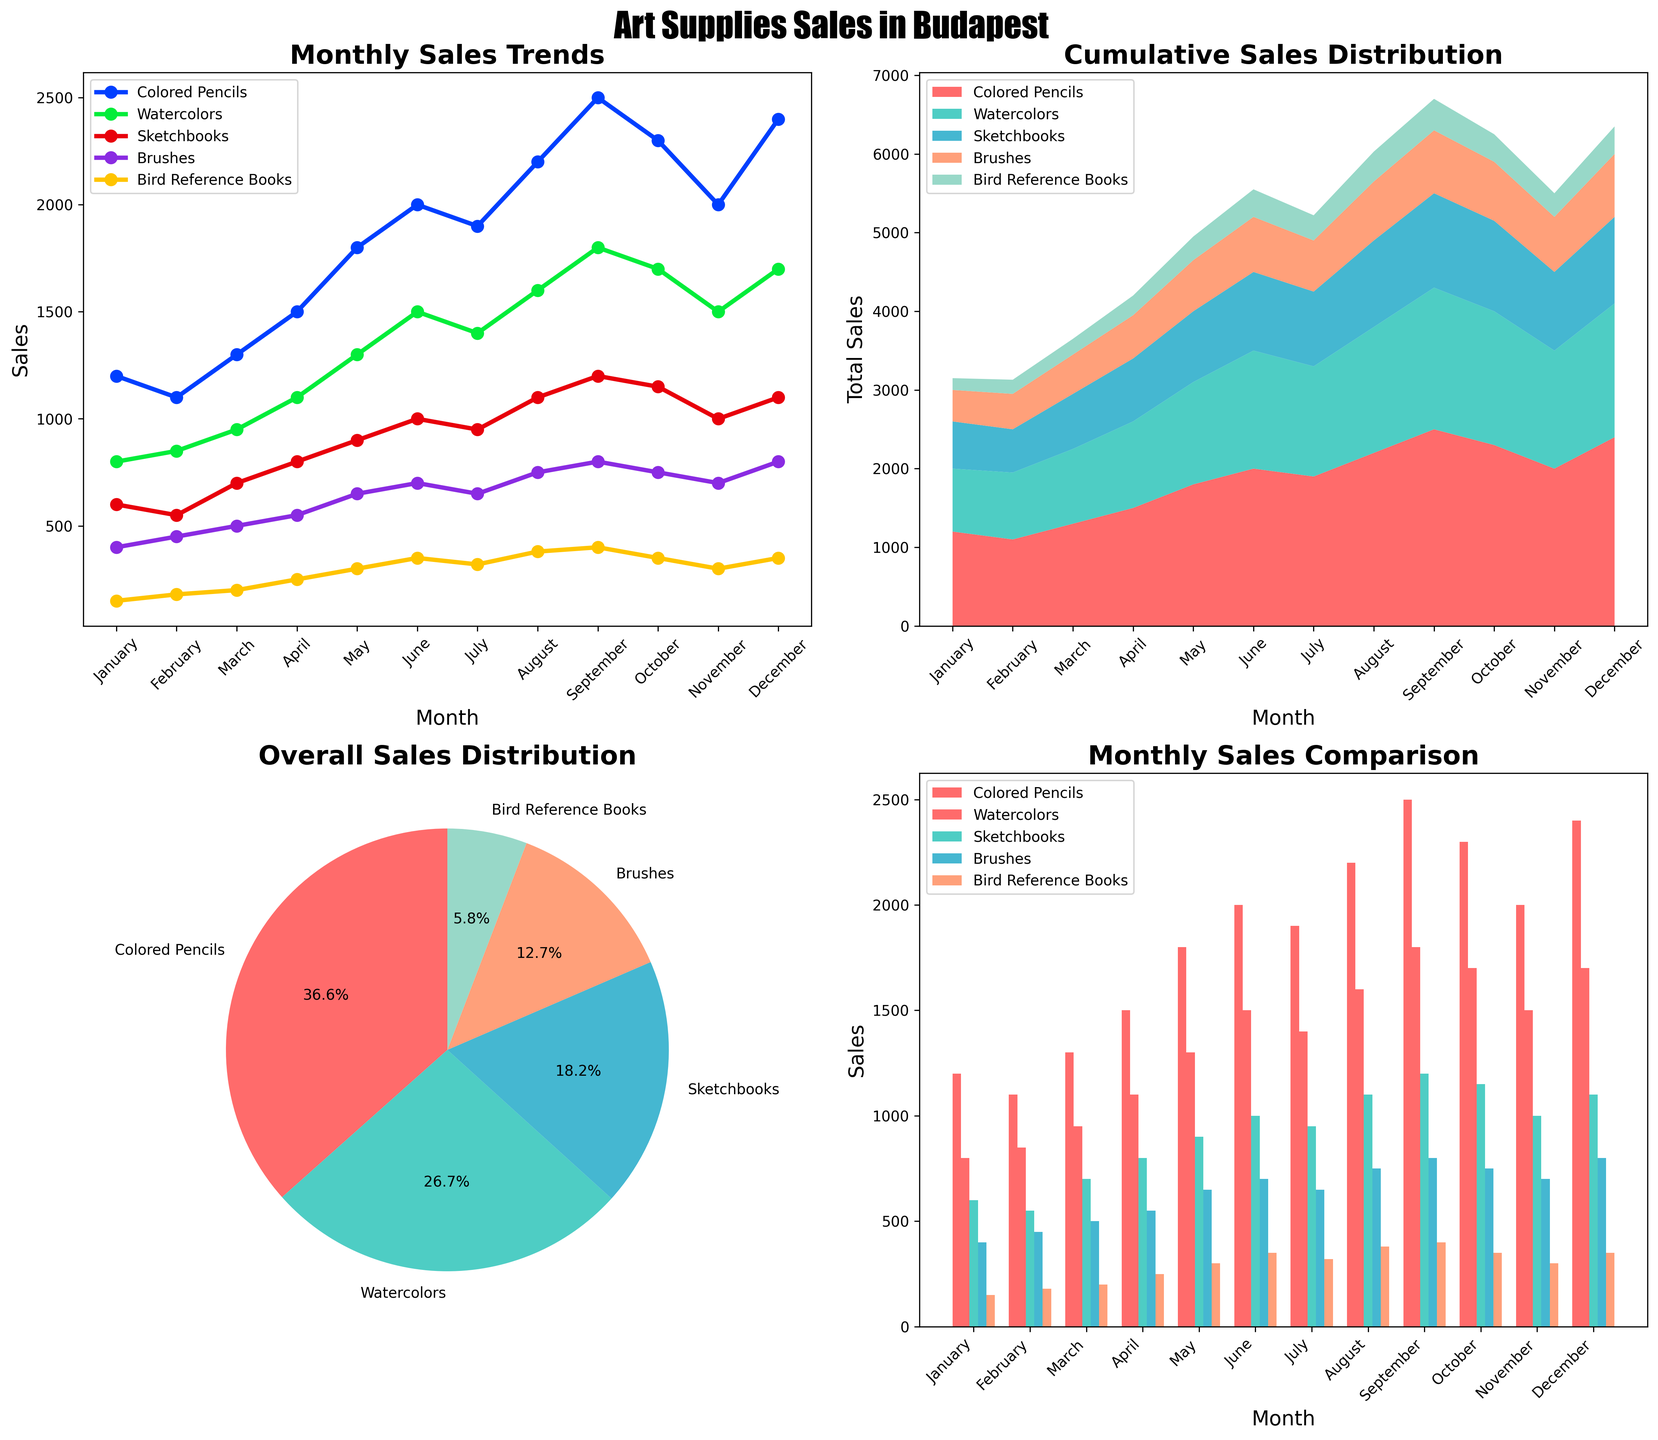What is the title of the figure? The title is usually located at the top of the figure and is meant to provide a brief description of what the figure is about. In this case, the title reads "Art Supplies Sales in Budapest".
Answer: Art Supplies Sales in Budapest Which art supply had the highest overall sales throughout the year in the pie chart? The pie chart shows the proportional distribution of the total sales of each art supply. Colored Pencils take up the largest portion of the pie chart.
Answer: Colored Pencils During which month did Colored Pencils have the highest sales according to the line plot? Look at the peak point of the line representing Colored Pencils in the line plot (first subplot). The peak occurs in September.
Answer: September Compare the sales of Colored Pencils and Watercolors in July as shown in the bar chart. Which one had higher sales and by how much? Look at the bars for July in the bar chart (last subplot) for both Colored Pencils and Watercolors, then compare their heights. Colored Pencils had 1900 sales, and Watercolors had 1400 sales, so the difference is 500 sales.
Answer: Colored Pencils, 500 What is the cumulative sales distribution trend over the months according to the stacked area chart? Observe the stacked area chart (second subplot). Notice how the total sales increase over the months consistently, with each layer representing a different art supply's sales contributing to the total. The trend shows a cumulative increase over time.
Answer: Increasing cumulatively over time What percentage of total sales did Brushes account for, as seen in the pie chart? Look at the pie chart (third subplot) and find the segment representing Brushes. The label on the segment shows it's 9.1%.
Answer: 9.1% In the line plot, which month experienced the steepest increase in sales of Bird Reference Books? Look at the line representing Bird Reference Books in the line plot (first subplot). The steepest increase is noted between April and May, where the slope is the greatest.
Answer: April to May Which month shows the least total sales across all art supplies based on the stacked area chart? Observe the lowest point on the stacked area chart (second subplot). The beginning of the year in January shows the least total sales.
Answer: January Calculate the average sales of Sketchbooks from the bar chart. Look at the heights of the bars representing Sketchbooks in each month in the bar chart (last subplot). Sum these values and divide by 12 to find the average. The total is (600+550+700+800+900+1000+950+1100+1200+1150+1000+1100) = 12050, then 12050 / 12 = 1004.2
Answer: 1004.2 